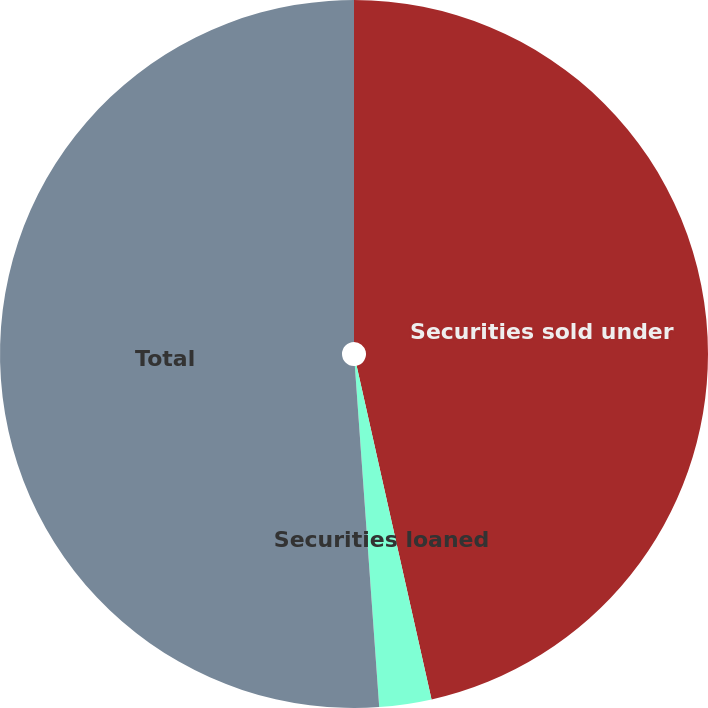<chart> <loc_0><loc_0><loc_500><loc_500><pie_chart><fcel>Securities sold under<fcel>Securities loaned<fcel>Total<nl><fcel>46.48%<fcel>2.38%<fcel>51.13%<nl></chart> 